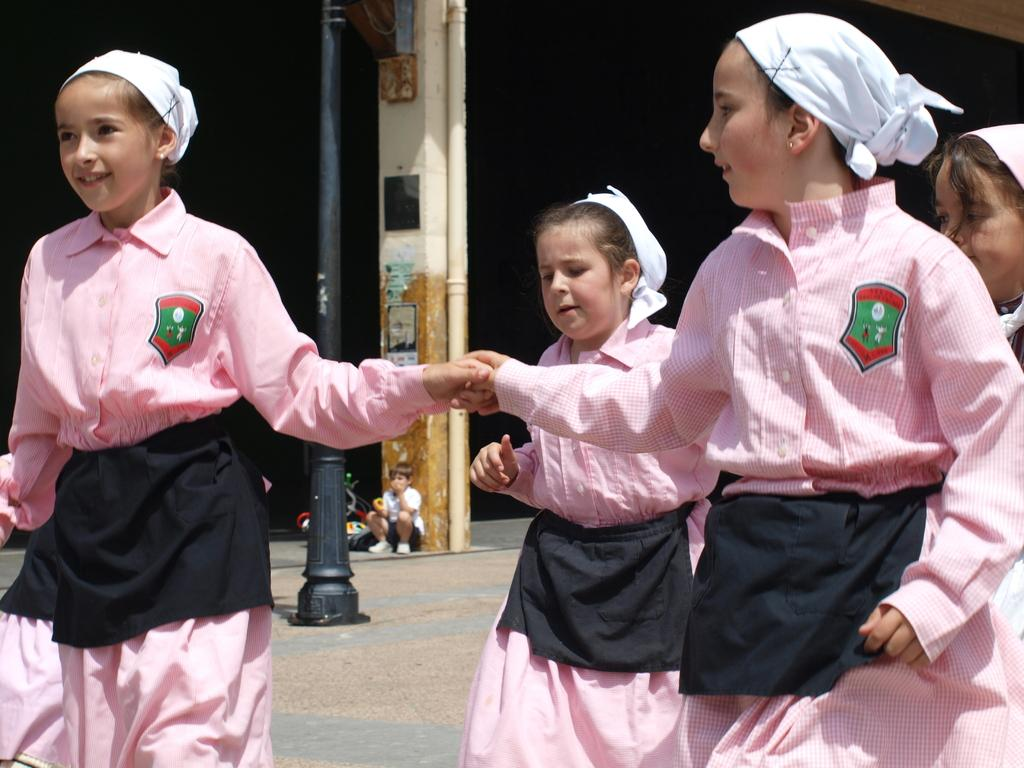What is the main subject of the image? The main subject of the image is a group of children. What can be seen in the center of the image? There is a pole in the center of the image. What is attached to the pillar in the image? There are posters on a pillar in the image. What other object can be seen in the image? There is a pipe in the image. What type of thunder can be heard in the image? There is no thunder present in the image, as it is a visual medium and does not contain sound. 